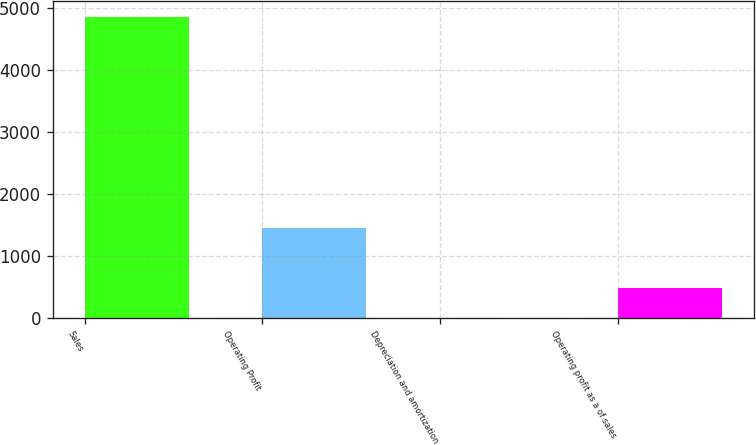Convert chart. <chart><loc_0><loc_0><loc_500><loc_500><bar_chart><fcel>Sales<fcel>Operating Profit<fcel>Depreciation and amortization<fcel>Operating profit as a of sales<nl><fcel>4860.8<fcel>1460.13<fcel>2.7<fcel>488.51<nl></chart> 